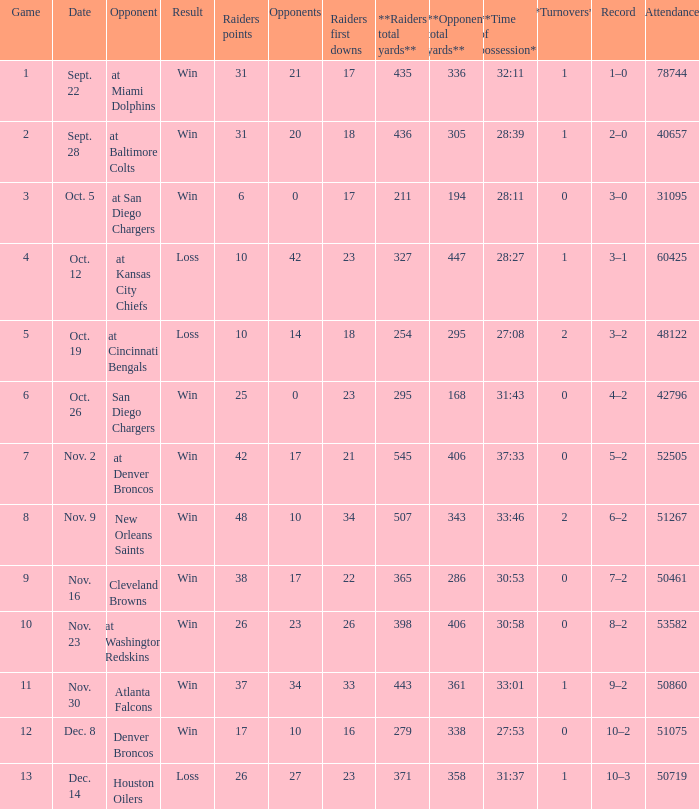How many different counts of the Raiders first downs are there for the game number 9? 1.0. 